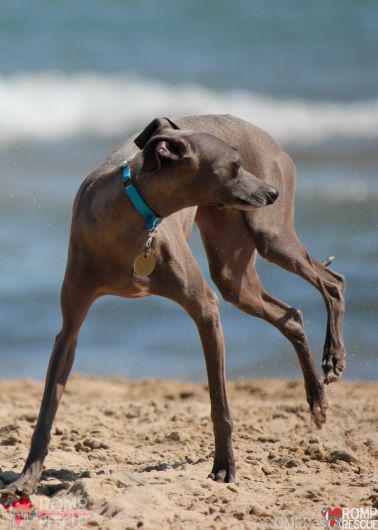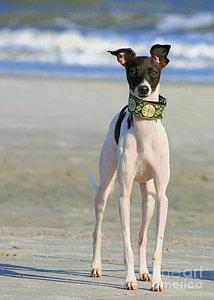The first image is the image on the left, the second image is the image on the right. Assess this claim about the two images: "One of the two dogs in the left image has its mouth open, displaying its teeth and a bit of tongue.". Correct or not? Answer yes or no. No. The first image is the image on the left, the second image is the image on the right. Given the left and right images, does the statement "Two dogs, one with an open mouth, are near one another on a sandy beach in one image." hold true? Answer yes or no. No. 